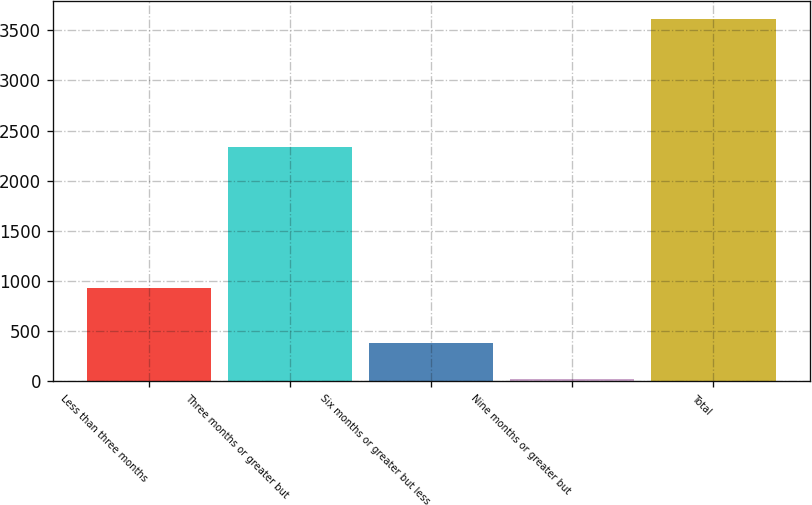<chart> <loc_0><loc_0><loc_500><loc_500><bar_chart><fcel>Less than three months<fcel>Three months or greater but<fcel>Six months or greater but less<fcel>Nine months or greater but<fcel>Total<nl><fcel>928<fcel>2338<fcel>380.1<fcel>21<fcel>3612<nl></chart> 